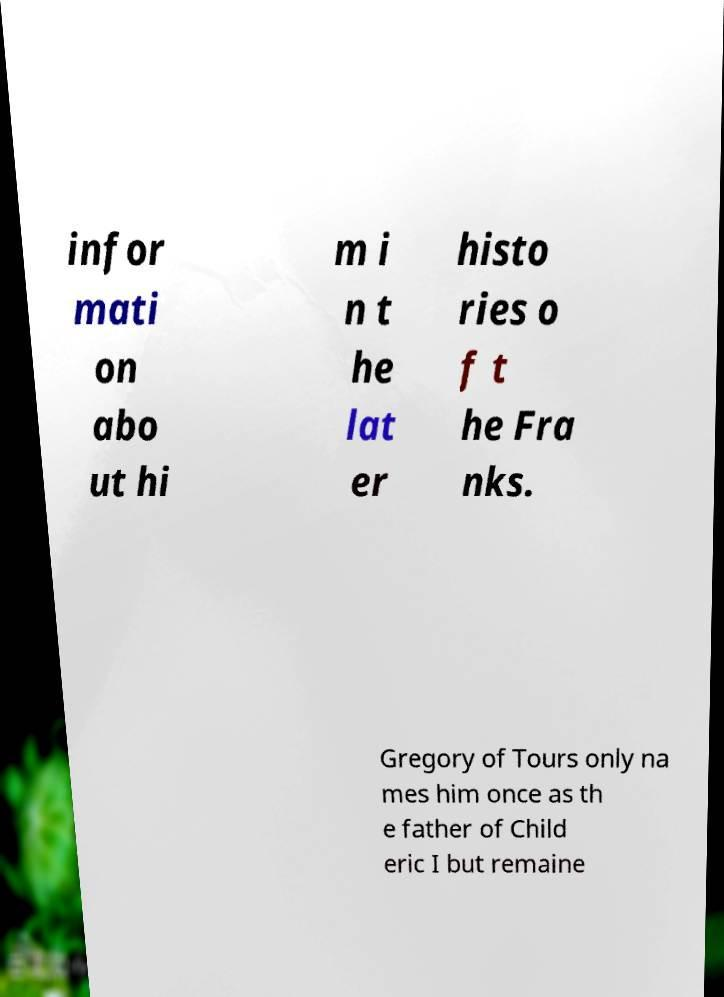Could you extract and type out the text from this image? infor mati on abo ut hi m i n t he lat er histo ries o f t he Fra nks. Gregory of Tours only na mes him once as th e father of Child eric I but remaine 